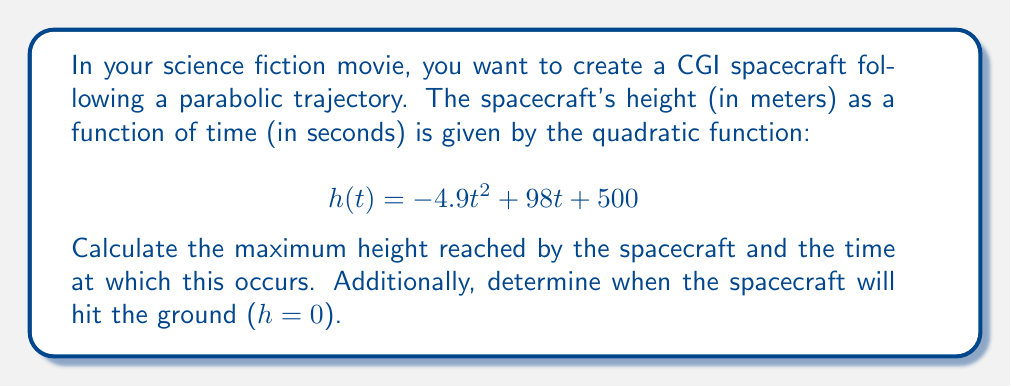Give your solution to this math problem. To solve this problem, we'll follow these steps:

1. Find the vertex of the parabola to determine the maximum height and when it occurs.
2. Use the quadratic formula to find when the spacecraft hits the ground.

Step 1: Finding the vertex

The quadratic function is in the form $h(t) = at^2 + bt + c$, where:
$a = -4.9$
$b = 98$
$c = 500$

For a quadratic function, the t-coordinate of the vertex is given by $t = -\frac{b}{2a}$:

$$ t = -\frac{98}{2(-4.9)} = 10 \text{ seconds} $$

To find the maximum height, we substitute this t-value back into the original function:

$$ h(10) = -4.9(10)^2 + 98(10) + 500 $$
$$ = -490 + 980 + 500 = 990 \text{ meters} $$

Step 2: Finding when the spacecraft hits the ground

To find when h(t) = 0, we solve the quadratic equation:

$$ -4.9t^2 + 98t + 500 = 0 $$

Using the quadratic formula $t = \frac{-b \pm \sqrt{b^2 - 4ac}}{2a}$:

$$ t = \frac{-98 \pm \sqrt{98^2 - 4(-4.9)(500)}}{2(-4.9)} $$
$$ = \frac{-98 \pm \sqrt{9604 + 9800}}{-9.8} $$
$$ = \frac{-98 \pm \sqrt{19404}}{-9.8} $$
$$ = \frac{-98 \pm 139.3}{-9.8} $$

This gives us two solutions:
$$ t_1 = \frac{-98 + 139.3}{-9.8} \approx 4.21 \text{ seconds} $$
$$ t_2 = \frac{-98 - 139.3}{-9.8} \approx 24.21 \text{ seconds} $$

The positive solution (24.21 seconds) is when the spacecraft hits the ground after reaching its maximum height.
Answer: Maximum height: 990 meters
Time of maximum height: 10 seconds
Time when spacecraft hits the ground: 24.21 seconds 